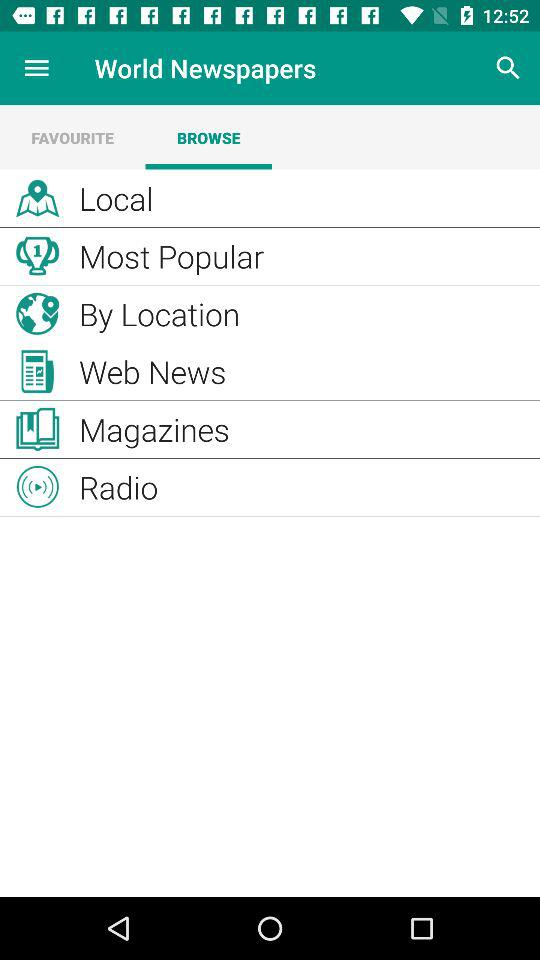How many notifications are there in "Radio"?
When the provided information is insufficient, respond with <no answer>. <no answer> 